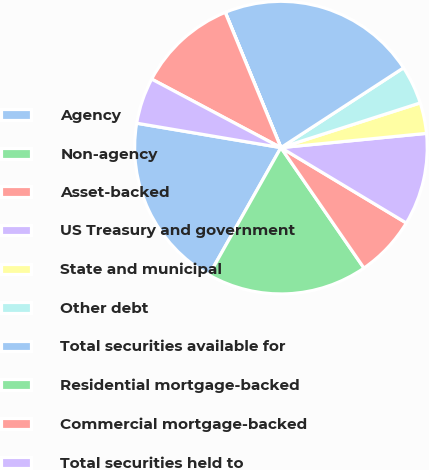Convert chart to OTSL. <chart><loc_0><loc_0><loc_500><loc_500><pie_chart><fcel>Agency<fcel>Non-agency<fcel>Asset-backed<fcel>US Treasury and government<fcel>State and municipal<fcel>Other debt<fcel>Total securities available for<fcel>Residential mortgage-backed<fcel>Commercial mortgage-backed<fcel>Total securities held to<nl><fcel>19.49%<fcel>17.79%<fcel>6.78%<fcel>10.17%<fcel>3.39%<fcel>4.24%<fcel>22.03%<fcel>0.01%<fcel>11.02%<fcel>5.09%<nl></chart> 